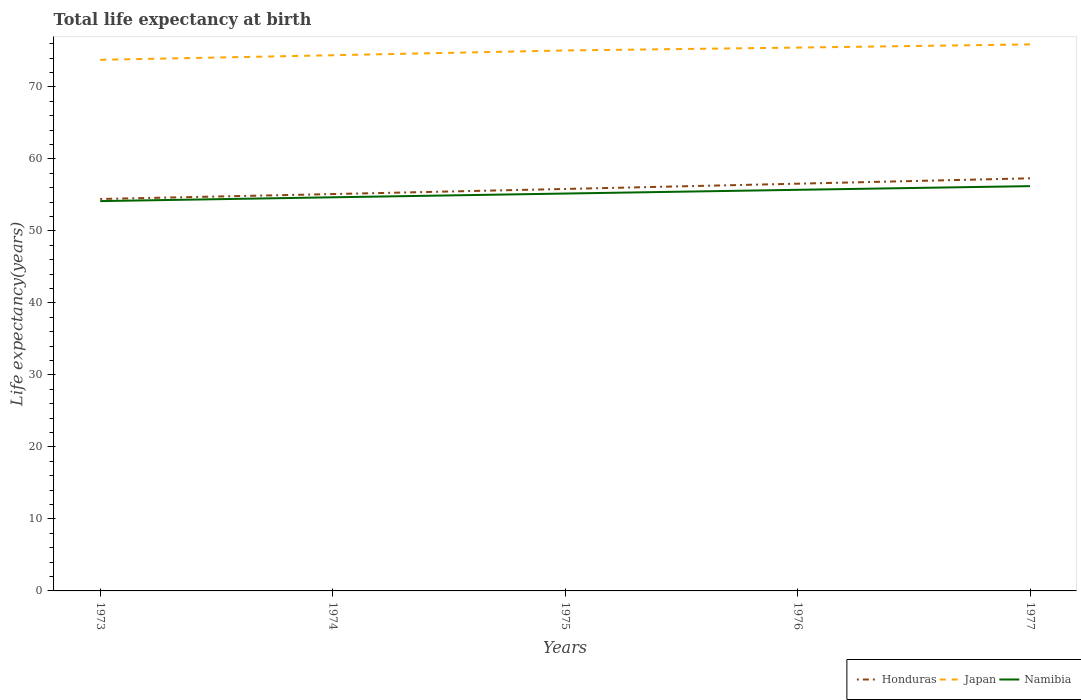Does the line corresponding to Japan intersect with the line corresponding to Namibia?
Give a very brief answer. No. Is the number of lines equal to the number of legend labels?
Make the answer very short. Yes. Across all years, what is the maximum life expectancy at birth in in Honduras?
Your answer should be very brief. 54.43. What is the total life expectancy at birth in in Honduras in the graph?
Provide a succinct answer. -2.12. What is the difference between the highest and the second highest life expectancy at birth in in Japan?
Offer a terse response. 2.14. What is the difference between the highest and the lowest life expectancy at birth in in Namibia?
Your response must be concise. 3. How many lines are there?
Offer a terse response. 3. How many years are there in the graph?
Offer a very short reply. 5. What is the difference between two consecutive major ticks on the Y-axis?
Your response must be concise. 10. Does the graph contain grids?
Give a very brief answer. No. Where does the legend appear in the graph?
Offer a terse response. Bottom right. How are the legend labels stacked?
Keep it short and to the point. Horizontal. What is the title of the graph?
Provide a short and direct response. Total life expectancy at birth. What is the label or title of the Y-axis?
Give a very brief answer. Life expectancy(years). What is the Life expectancy(years) in Honduras in 1973?
Keep it short and to the point. 54.43. What is the Life expectancy(years) of Japan in 1973?
Make the answer very short. 73.76. What is the Life expectancy(years) in Namibia in 1973?
Your response must be concise. 54.14. What is the Life expectancy(years) of Honduras in 1974?
Provide a succinct answer. 55.12. What is the Life expectancy(years) in Japan in 1974?
Give a very brief answer. 74.39. What is the Life expectancy(years) of Namibia in 1974?
Provide a succinct answer. 54.66. What is the Life expectancy(years) in Honduras in 1975?
Offer a terse response. 55.82. What is the Life expectancy(years) of Japan in 1975?
Offer a very short reply. 75.06. What is the Life expectancy(years) of Namibia in 1975?
Keep it short and to the point. 55.19. What is the Life expectancy(years) of Honduras in 1976?
Your answer should be compact. 56.55. What is the Life expectancy(years) in Japan in 1976?
Provide a short and direct response. 75.46. What is the Life expectancy(years) of Namibia in 1976?
Offer a terse response. 55.7. What is the Life expectancy(years) of Honduras in 1977?
Your response must be concise. 57.3. What is the Life expectancy(years) in Japan in 1977?
Keep it short and to the point. 75.9. What is the Life expectancy(years) of Namibia in 1977?
Your answer should be compact. 56.21. Across all years, what is the maximum Life expectancy(years) of Honduras?
Ensure brevity in your answer.  57.3. Across all years, what is the maximum Life expectancy(years) in Japan?
Your answer should be compact. 75.9. Across all years, what is the maximum Life expectancy(years) of Namibia?
Your response must be concise. 56.21. Across all years, what is the minimum Life expectancy(years) in Honduras?
Your response must be concise. 54.43. Across all years, what is the minimum Life expectancy(years) of Japan?
Your answer should be compact. 73.76. Across all years, what is the minimum Life expectancy(years) in Namibia?
Offer a very short reply. 54.14. What is the total Life expectancy(years) of Honduras in the graph?
Make the answer very short. 279.23. What is the total Life expectancy(years) of Japan in the graph?
Keep it short and to the point. 374.56. What is the total Life expectancy(years) in Namibia in the graph?
Give a very brief answer. 275.91. What is the difference between the Life expectancy(years) in Honduras in 1973 and that in 1974?
Your answer should be very brief. -0.68. What is the difference between the Life expectancy(years) in Japan in 1973 and that in 1974?
Keep it short and to the point. -0.64. What is the difference between the Life expectancy(years) of Namibia in 1973 and that in 1974?
Your answer should be compact. -0.53. What is the difference between the Life expectancy(years) in Honduras in 1973 and that in 1975?
Ensure brevity in your answer.  -1.39. What is the difference between the Life expectancy(years) in Japan in 1973 and that in 1975?
Make the answer very short. -1.3. What is the difference between the Life expectancy(years) in Namibia in 1973 and that in 1975?
Provide a succinct answer. -1.05. What is the difference between the Life expectancy(years) of Honduras in 1973 and that in 1976?
Your answer should be compact. -2.12. What is the difference between the Life expectancy(years) of Japan in 1973 and that in 1976?
Your answer should be compact. -1.7. What is the difference between the Life expectancy(years) of Namibia in 1973 and that in 1976?
Give a very brief answer. -1.57. What is the difference between the Life expectancy(years) in Honduras in 1973 and that in 1977?
Offer a terse response. -2.87. What is the difference between the Life expectancy(years) of Japan in 1973 and that in 1977?
Give a very brief answer. -2.14. What is the difference between the Life expectancy(years) in Namibia in 1973 and that in 1977?
Provide a succinct answer. -2.08. What is the difference between the Life expectancy(years) of Honduras in 1974 and that in 1975?
Provide a succinct answer. -0.71. What is the difference between the Life expectancy(years) of Japan in 1974 and that in 1975?
Provide a succinct answer. -0.66. What is the difference between the Life expectancy(years) of Namibia in 1974 and that in 1975?
Keep it short and to the point. -0.52. What is the difference between the Life expectancy(years) in Honduras in 1974 and that in 1976?
Your answer should be compact. -1.44. What is the difference between the Life expectancy(years) of Japan in 1974 and that in 1976?
Give a very brief answer. -1.06. What is the difference between the Life expectancy(years) of Namibia in 1974 and that in 1976?
Provide a succinct answer. -1.04. What is the difference between the Life expectancy(years) in Honduras in 1974 and that in 1977?
Keep it short and to the point. -2.19. What is the difference between the Life expectancy(years) in Japan in 1974 and that in 1977?
Give a very brief answer. -1.5. What is the difference between the Life expectancy(years) in Namibia in 1974 and that in 1977?
Provide a short and direct response. -1.55. What is the difference between the Life expectancy(years) of Honduras in 1975 and that in 1976?
Make the answer very short. -0.73. What is the difference between the Life expectancy(years) in Japan in 1975 and that in 1976?
Provide a succinct answer. -0.4. What is the difference between the Life expectancy(years) of Namibia in 1975 and that in 1976?
Provide a short and direct response. -0.52. What is the difference between the Life expectancy(years) in Honduras in 1975 and that in 1977?
Ensure brevity in your answer.  -1.48. What is the difference between the Life expectancy(years) of Japan in 1975 and that in 1977?
Offer a terse response. -0.84. What is the difference between the Life expectancy(years) in Namibia in 1975 and that in 1977?
Offer a terse response. -1.03. What is the difference between the Life expectancy(years) of Honduras in 1976 and that in 1977?
Offer a terse response. -0.75. What is the difference between the Life expectancy(years) in Japan in 1976 and that in 1977?
Your response must be concise. -0.44. What is the difference between the Life expectancy(years) in Namibia in 1976 and that in 1977?
Make the answer very short. -0.51. What is the difference between the Life expectancy(years) of Honduras in 1973 and the Life expectancy(years) of Japan in 1974?
Provide a short and direct response. -19.96. What is the difference between the Life expectancy(years) of Honduras in 1973 and the Life expectancy(years) of Namibia in 1974?
Your response must be concise. -0.23. What is the difference between the Life expectancy(years) of Japan in 1973 and the Life expectancy(years) of Namibia in 1974?
Your response must be concise. 19.09. What is the difference between the Life expectancy(years) of Honduras in 1973 and the Life expectancy(years) of Japan in 1975?
Give a very brief answer. -20.63. What is the difference between the Life expectancy(years) in Honduras in 1973 and the Life expectancy(years) in Namibia in 1975?
Your answer should be compact. -0.76. What is the difference between the Life expectancy(years) in Japan in 1973 and the Life expectancy(years) in Namibia in 1975?
Provide a short and direct response. 18.57. What is the difference between the Life expectancy(years) of Honduras in 1973 and the Life expectancy(years) of Japan in 1976?
Your answer should be very brief. -21.03. What is the difference between the Life expectancy(years) of Honduras in 1973 and the Life expectancy(years) of Namibia in 1976?
Your answer should be very brief. -1.27. What is the difference between the Life expectancy(years) in Japan in 1973 and the Life expectancy(years) in Namibia in 1976?
Your answer should be very brief. 18.05. What is the difference between the Life expectancy(years) in Honduras in 1973 and the Life expectancy(years) in Japan in 1977?
Your answer should be compact. -21.47. What is the difference between the Life expectancy(years) in Honduras in 1973 and the Life expectancy(years) in Namibia in 1977?
Offer a very short reply. -1.78. What is the difference between the Life expectancy(years) of Japan in 1973 and the Life expectancy(years) of Namibia in 1977?
Offer a terse response. 17.54. What is the difference between the Life expectancy(years) in Honduras in 1974 and the Life expectancy(years) in Japan in 1975?
Ensure brevity in your answer.  -19.94. What is the difference between the Life expectancy(years) of Honduras in 1974 and the Life expectancy(years) of Namibia in 1975?
Keep it short and to the point. -0.07. What is the difference between the Life expectancy(years) in Japan in 1974 and the Life expectancy(years) in Namibia in 1975?
Your answer should be compact. 19.21. What is the difference between the Life expectancy(years) of Honduras in 1974 and the Life expectancy(years) of Japan in 1976?
Provide a succinct answer. -20.34. What is the difference between the Life expectancy(years) in Honduras in 1974 and the Life expectancy(years) in Namibia in 1976?
Your answer should be compact. -0.59. What is the difference between the Life expectancy(years) of Japan in 1974 and the Life expectancy(years) of Namibia in 1976?
Your response must be concise. 18.69. What is the difference between the Life expectancy(years) in Honduras in 1974 and the Life expectancy(years) in Japan in 1977?
Your answer should be compact. -20.78. What is the difference between the Life expectancy(years) in Honduras in 1974 and the Life expectancy(years) in Namibia in 1977?
Provide a succinct answer. -1.1. What is the difference between the Life expectancy(years) in Japan in 1974 and the Life expectancy(years) in Namibia in 1977?
Keep it short and to the point. 18.18. What is the difference between the Life expectancy(years) in Honduras in 1975 and the Life expectancy(years) in Japan in 1976?
Provide a succinct answer. -19.63. What is the difference between the Life expectancy(years) in Honduras in 1975 and the Life expectancy(years) in Namibia in 1976?
Ensure brevity in your answer.  0.12. What is the difference between the Life expectancy(years) in Japan in 1975 and the Life expectancy(years) in Namibia in 1976?
Keep it short and to the point. 19.35. What is the difference between the Life expectancy(years) of Honduras in 1975 and the Life expectancy(years) of Japan in 1977?
Your answer should be compact. -20.07. What is the difference between the Life expectancy(years) of Honduras in 1975 and the Life expectancy(years) of Namibia in 1977?
Make the answer very short. -0.39. What is the difference between the Life expectancy(years) in Japan in 1975 and the Life expectancy(years) in Namibia in 1977?
Offer a terse response. 18.84. What is the difference between the Life expectancy(years) in Honduras in 1976 and the Life expectancy(years) in Japan in 1977?
Your answer should be compact. -19.34. What is the difference between the Life expectancy(years) in Honduras in 1976 and the Life expectancy(years) in Namibia in 1977?
Provide a succinct answer. 0.34. What is the difference between the Life expectancy(years) in Japan in 1976 and the Life expectancy(years) in Namibia in 1977?
Provide a short and direct response. 19.24. What is the average Life expectancy(years) of Honduras per year?
Offer a terse response. 55.85. What is the average Life expectancy(years) in Japan per year?
Your answer should be very brief. 74.91. What is the average Life expectancy(years) in Namibia per year?
Your answer should be compact. 55.18. In the year 1973, what is the difference between the Life expectancy(years) of Honduras and Life expectancy(years) of Japan?
Your answer should be compact. -19.33. In the year 1973, what is the difference between the Life expectancy(years) of Honduras and Life expectancy(years) of Namibia?
Offer a very short reply. 0.29. In the year 1973, what is the difference between the Life expectancy(years) in Japan and Life expectancy(years) in Namibia?
Your answer should be very brief. 19.62. In the year 1974, what is the difference between the Life expectancy(years) in Honduras and Life expectancy(years) in Japan?
Keep it short and to the point. -19.28. In the year 1974, what is the difference between the Life expectancy(years) of Honduras and Life expectancy(years) of Namibia?
Make the answer very short. 0.45. In the year 1974, what is the difference between the Life expectancy(years) in Japan and Life expectancy(years) in Namibia?
Keep it short and to the point. 19.73. In the year 1975, what is the difference between the Life expectancy(years) of Honduras and Life expectancy(years) of Japan?
Give a very brief answer. -19.23. In the year 1975, what is the difference between the Life expectancy(years) of Honduras and Life expectancy(years) of Namibia?
Your answer should be compact. 0.64. In the year 1975, what is the difference between the Life expectancy(years) in Japan and Life expectancy(years) in Namibia?
Your answer should be compact. 19.87. In the year 1976, what is the difference between the Life expectancy(years) in Honduras and Life expectancy(years) in Japan?
Give a very brief answer. -18.9. In the year 1976, what is the difference between the Life expectancy(years) of Honduras and Life expectancy(years) of Namibia?
Ensure brevity in your answer.  0.85. In the year 1976, what is the difference between the Life expectancy(years) in Japan and Life expectancy(years) in Namibia?
Your answer should be very brief. 19.75. In the year 1977, what is the difference between the Life expectancy(years) of Honduras and Life expectancy(years) of Japan?
Keep it short and to the point. -18.6. In the year 1977, what is the difference between the Life expectancy(years) in Honduras and Life expectancy(years) in Namibia?
Ensure brevity in your answer.  1.09. In the year 1977, what is the difference between the Life expectancy(years) in Japan and Life expectancy(years) in Namibia?
Your answer should be compact. 19.68. What is the ratio of the Life expectancy(years) of Honduras in 1973 to that in 1974?
Provide a short and direct response. 0.99. What is the ratio of the Life expectancy(years) of Japan in 1973 to that in 1974?
Offer a very short reply. 0.99. What is the ratio of the Life expectancy(years) of Namibia in 1973 to that in 1974?
Offer a very short reply. 0.99. What is the ratio of the Life expectancy(years) of Honduras in 1973 to that in 1975?
Provide a succinct answer. 0.98. What is the ratio of the Life expectancy(years) of Japan in 1973 to that in 1975?
Provide a short and direct response. 0.98. What is the ratio of the Life expectancy(years) of Namibia in 1973 to that in 1975?
Provide a succinct answer. 0.98. What is the ratio of the Life expectancy(years) of Honduras in 1973 to that in 1976?
Your answer should be compact. 0.96. What is the ratio of the Life expectancy(years) in Japan in 1973 to that in 1976?
Keep it short and to the point. 0.98. What is the ratio of the Life expectancy(years) of Namibia in 1973 to that in 1976?
Keep it short and to the point. 0.97. What is the ratio of the Life expectancy(years) of Honduras in 1973 to that in 1977?
Keep it short and to the point. 0.95. What is the ratio of the Life expectancy(years) of Japan in 1973 to that in 1977?
Your response must be concise. 0.97. What is the ratio of the Life expectancy(years) in Honduras in 1974 to that in 1975?
Provide a short and direct response. 0.99. What is the ratio of the Life expectancy(years) in Japan in 1974 to that in 1975?
Give a very brief answer. 0.99. What is the ratio of the Life expectancy(years) in Honduras in 1974 to that in 1976?
Offer a very short reply. 0.97. What is the ratio of the Life expectancy(years) in Japan in 1974 to that in 1976?
Make the answer very short. 0.99. What is the ratio of the Life expectancy(years) of Namibia in 1974 to that in 1976?
Offer a very short reply. 0.98. What is the ratio of the Life expectancy(years) in Honduras in 1974 to that in 1977?
Make the answer very short. 0.96. What is the ratio of the Life expectancy(years) of Japan in 1974 to that in 1977?
Keep it short and to the point. 0.98. What is the ratio of the Life expectancy(years) of Namibia in 1974 to that in 1977?
Make the answer very short. 0.97. What is the ratio of the Life expectancy(years) of Honduras in 1975 to that in 1976?
Provide a succinct answer. 0.99. What is the ratio of the Life expectancy(years) in Namibia in 1975 to that in 1976?
Ensure brevity in your answer.  0.99. What is the ratio of the Life expectancy(years) of Honduras in 1975 to that in 1977?
Offer a terse response. 0.97. What is the ratio of the Life expectancy(years) of Japan in 1975 to that in 1977?
Offer a very short reply. 0.99. What is the ratio of the Life expectancy(years) in Namibia in 1975 to that in 1977?
Offer a terse response. 0.98. What is the ratio of the Life expectancy(years) in Honduras in 1976 to that in 1977?
Your answer should be very brief. 0.99. What is the ratio of the Life expectancy(years) in Namibia in 1976 to that in 1977?
Provide a succinct answer. 0.99. What is the difference between the highest and the second highest Life expectancy(years) in Honduras?
Your response must be concise. 0.75. What is the difference between the highest and the second highest Life expectancy(years) of Japan?
Offer a very short reply. 0.44. What is the difference between the highest and the second highest Life expectancy(years) of Namibia?
Your answer should be compact. 0.51. What is the difference between the highest and the lowest Life expectancy(years) of Honduras?
Your response must be concise. 2.87. What is the difference between the highest and the lowest Life expectancy(years) of Japan?
Your answer should be very brief. 2.14. What is the difference between the highest and the lowest Life expectancy(years) in Namibia?
Ensure brevity in your answer.  2.08. 